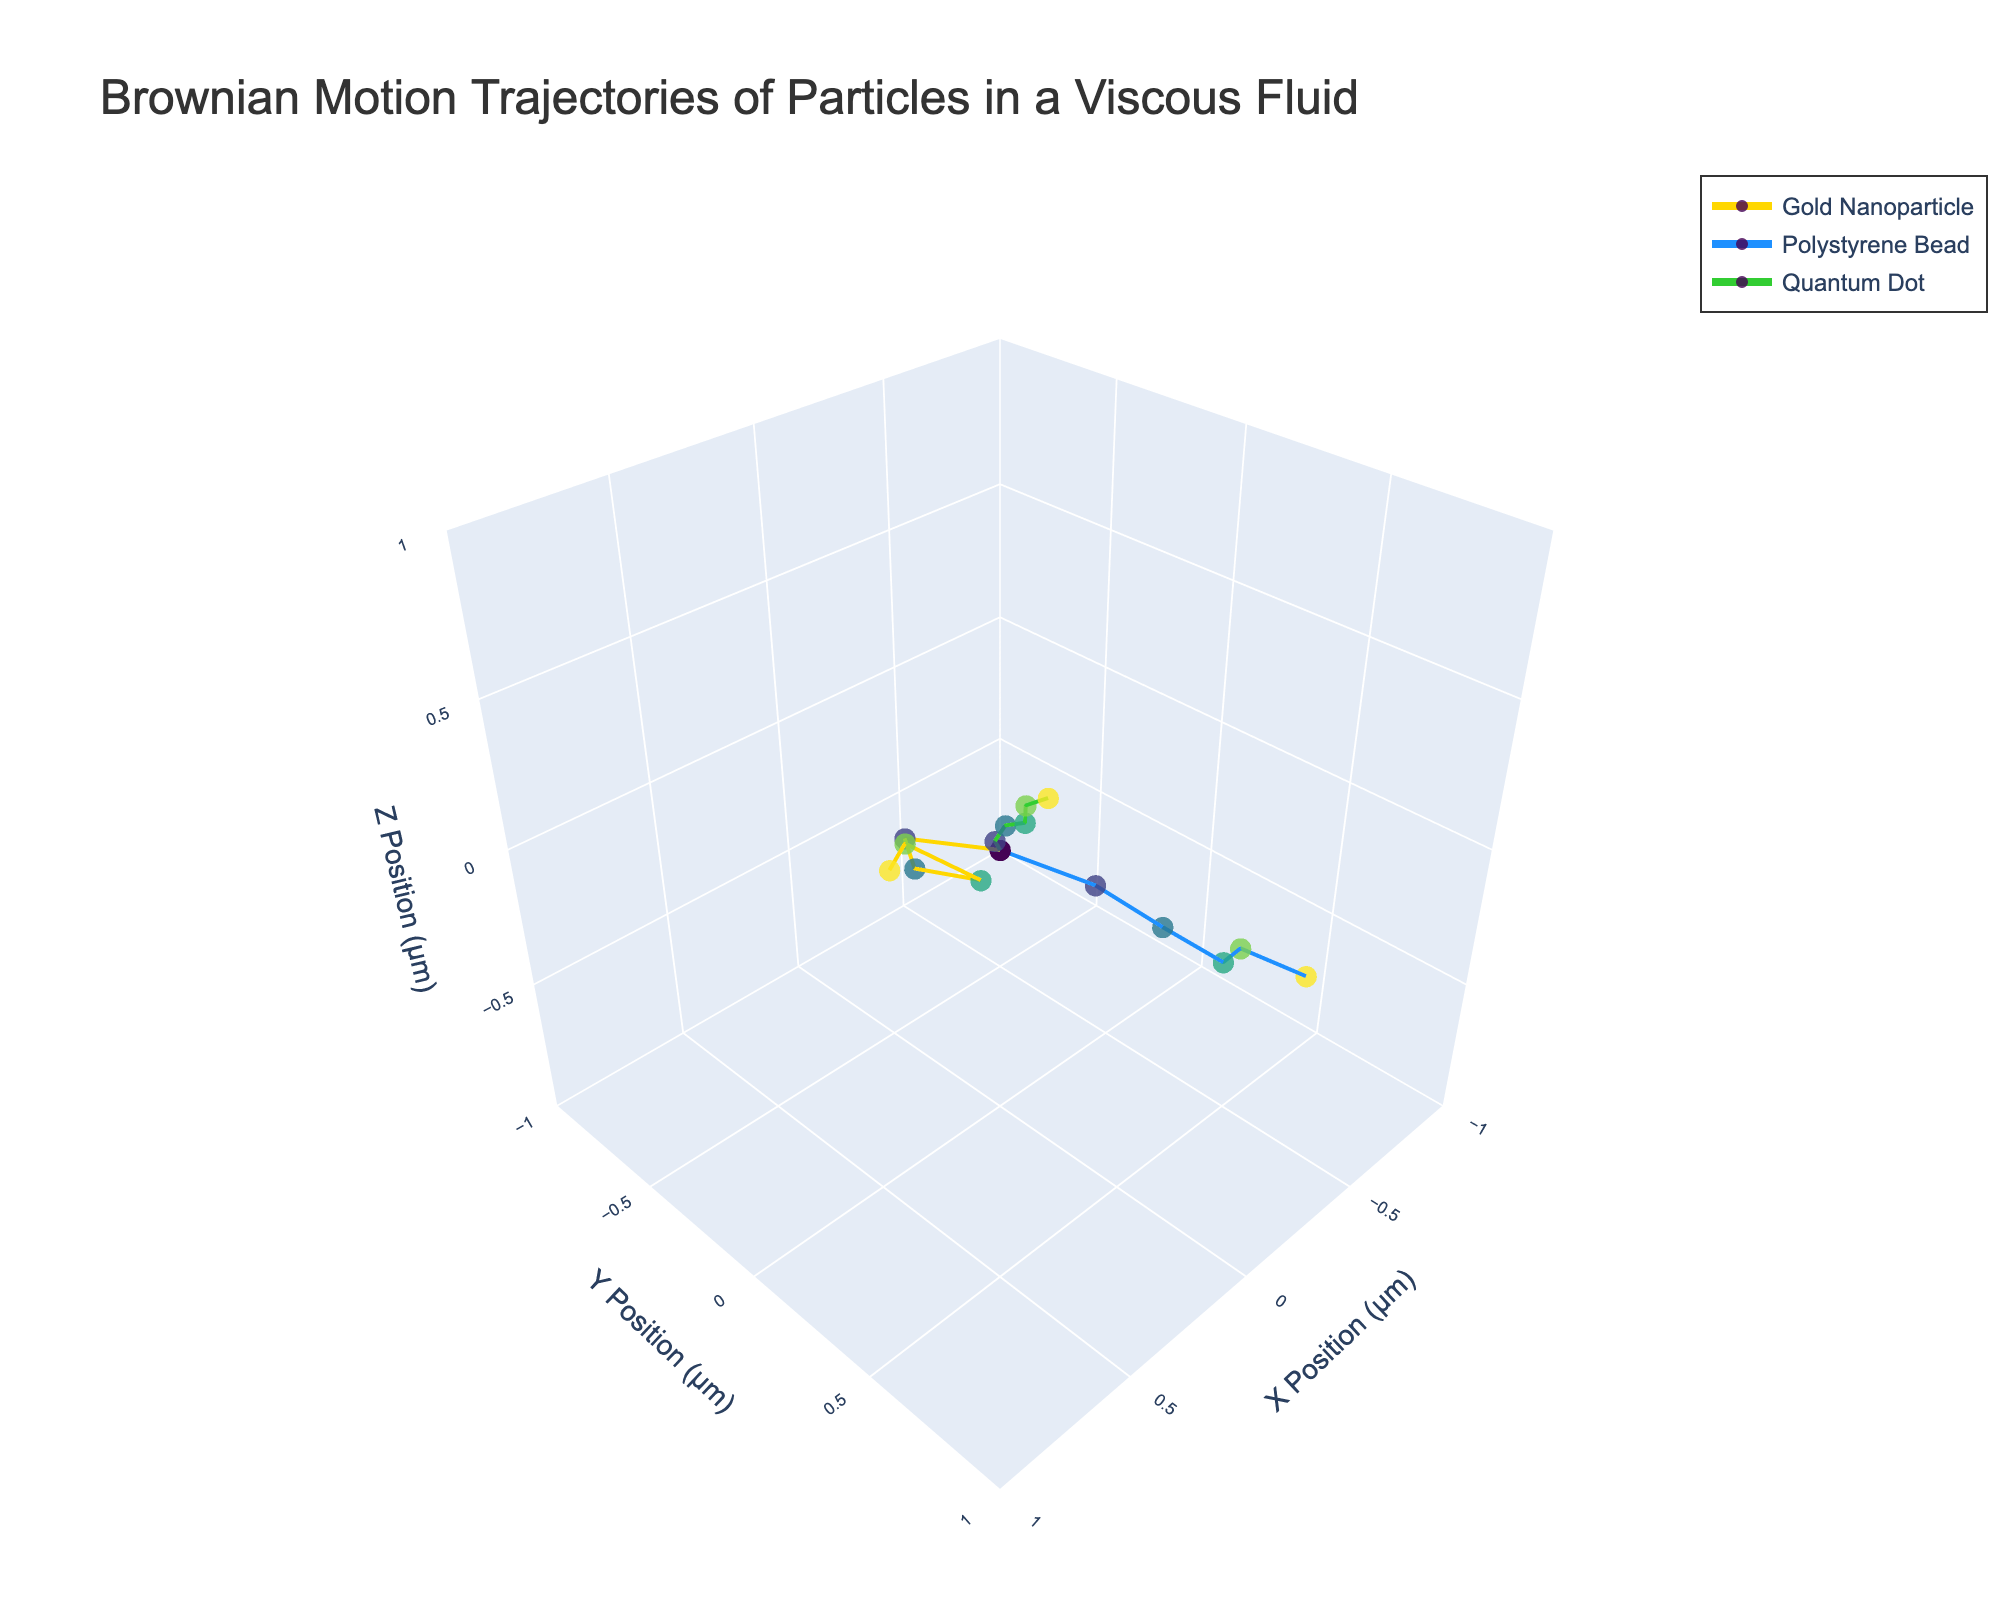What is the title of the plot? The title of the plot is displayed prominently at the top of the figure, typically in a larger and bold font for visibility. The title in this case is "Brownian Motion Trajectories of Particles in a Viscous Fluid".
Answer: Brownian Motion Trajectories of Particles in a Viscous Fluid What particles are being tracked in this figure? The legend, usually located on the side of the plot, shows the names of the particles being tracked. The particles are "Gold Nanoparticle", "Polystyrene Bead", and "Quantum Dot".
Answer: Gold Nanoparticle, Polystyrene Bead, Quantum Dot How does the trajectory of the Gold Nanoparticle compare to the Polystyrene Bead by 0.5 seconds? By examining the end points of the trajectories at 0.5 seconds, the Gold Nanoparticle has moved to approximately (0.67, 0.29, 0.42), while the Polystyrene Bead has moved to approximately (-0.72, 0.61, -0.53). The Polystyrene Bead shows a larger overall displacement compared to the Gold Nanoparticle.
Answer: Polystyrene Bead has a larger displacement Which particle exhibits the largest displacement along the X-axis by 0.5 seconds? To find the particle with the largest displacement along the X-axis, compare the absolute X positions of each particle at 0.5 seconds. The Gold Nanoparticle is at 0.67 μm, the Polystyrene Bead is at -0.72 μm (absolute value 0.72 μm), and the Quantum Dot is at 0.41 μm. Therefore, the Polystyrene Bead exhibits the largest displacement along the X-axis.
Answer: Polystyrene Bead What are the axis labels for the plot's 3D coordinate system? The axis labels are usually indicated next to each axis line and in this figure, they are "X Position (μm)" for the x-axis, "Y Position (μm)" for the y-axis, and "Z Position (μm)" for the z-axis.
Answer: X Position (μm), Y Position (μm), Z Position (μm) At what range are the axis scales set for the plot? The scale range for each axis can be observed by looking at the tick values. Each axis (X, Y, and Z) has a range from -1 to 1.
Answer: -1 to 1 Which particle has the smoothest trajectory appearance in the plot? By visually inspecting the trajectories, the Quantum Dot shows the smoothest path indicating that its motion is less erratic compared to the Gold Nanoparticle and Polystyrene Bead. This is inferred by the fewer and smaller deviations in its path.
Answer: Quantum Dot How do the color variations represent the passage of time in the trajectories? The color variations along the trajectories correspond to the time in seconds, from 0 to 0.5. The color gradient follows a Viridis color scale where colors transition from one shade to another across the trajectory indicating the progression of time.
Answer: Colors represent time progression Are there any time intervals where two particles cross each other's path? By examining the trajectories, the paths of the Gold Nanoparticle and Polystyrene Bead cross each other near (0.2 seconds) in the X,Y,Z coordinate space, showing moments when their positions intersect.
Answer: Yes, near 0.2 seconds What is the camera angle configuration used to view the 3D scatter plot? The plot's 3D camera angle is set such that the eye is positioned at (1.5, 1.5, 1.5), providing a perspective that allows for a balanced view of all three axes and their respective ranges.
Answer: (1.5, 1.5, 1.5) 